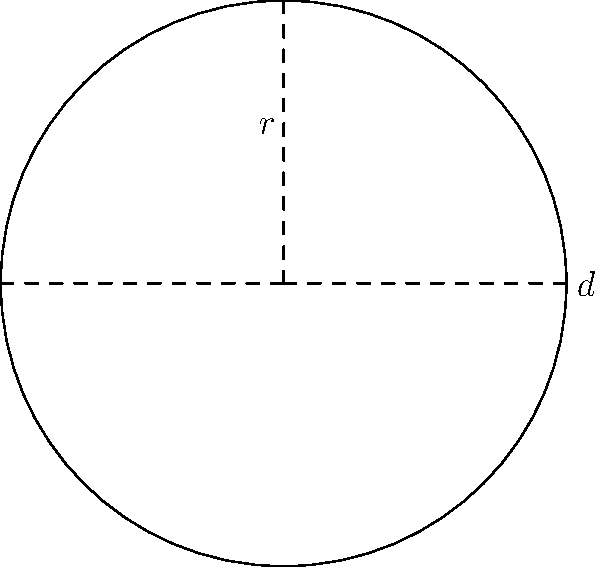Your innovative startup has designed a spherical product display for a tech showcase. If the diameter of the display is 6 meters, what is the total surface area of the display in square meters? Round your answer to two decimal places. To find the surface area of a sphere, we need to follow these steps:

1) The formula for the surface area of a sphere is:
   $A = 4\pi r^2$
   where $A$ is the surface area and $r$ is the radius.

2) We are given the diameter $d = 6$ meters. The radius is half of the diameter:
   $r = \frac{d}{2} = \frac{6}{2} = 3$ meters

3) Now we can substitute this into our formula:
   $A = 4\pi (3)^2$

4) Simplify:
   $A = 4\pi (9) = 36\pi$

5) Calculate and round to two decimal places:
   $A \approx 113.10$ square meters

Therefore, the surface area of the spherical product display is approximately 113.10 square meters.
Answer: 113.10 m² 